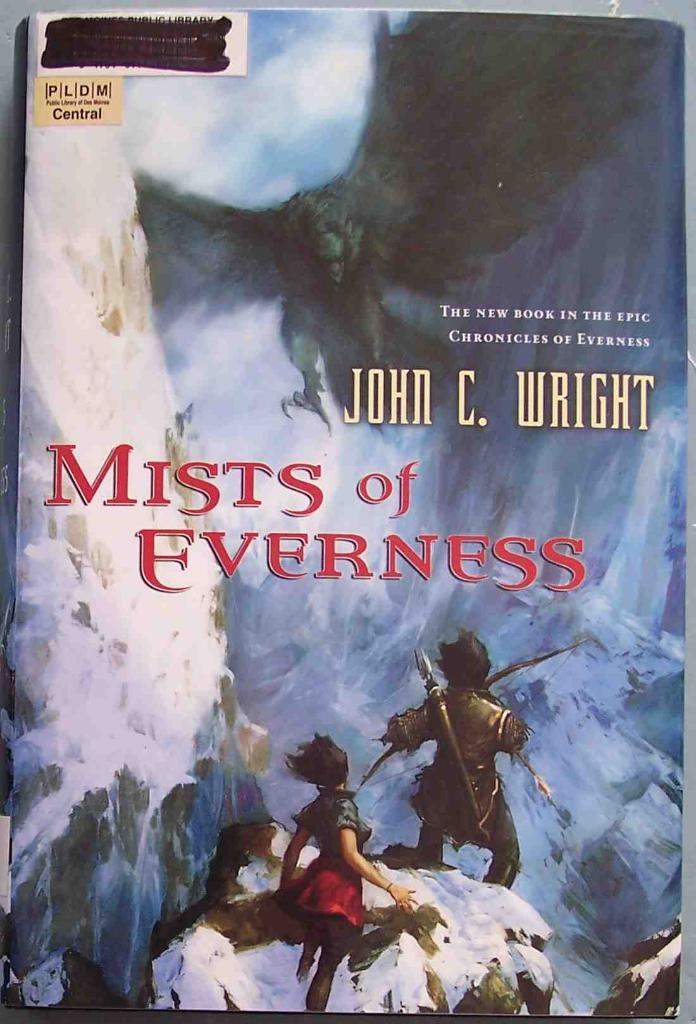Provide a one-sentence caption for the provided image. The book Mists of Everness was written by John C. Wright. 